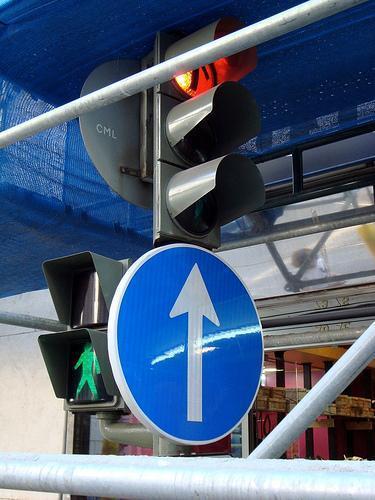How many blue signs are there?
Give a very brief answer. 1. 